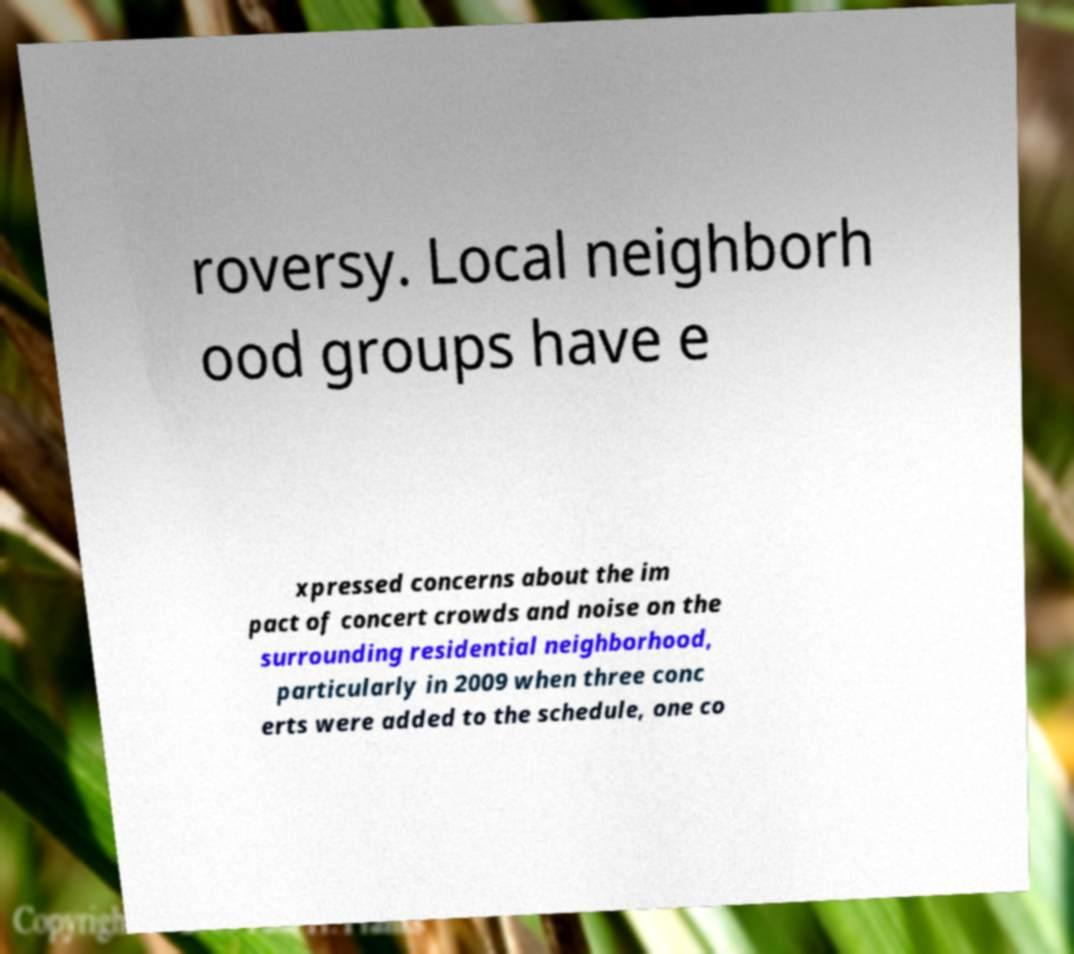I need the written content from this picture converted into text. Can you do that? roversy. Local neighborh ood groups have e xpressed concerns about the im pact of concert crowds and noise on the surrounding residential neighborhood, particularly in 2009 when three conc erts were added to the schedule, one co 